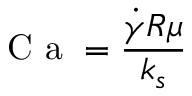Convert formula to latex. <formula><loc_0><loc_0><loc_500><loc_500>C a = \frac { \dot { \gamma } R \mu } { k _ { s } }</formula> 